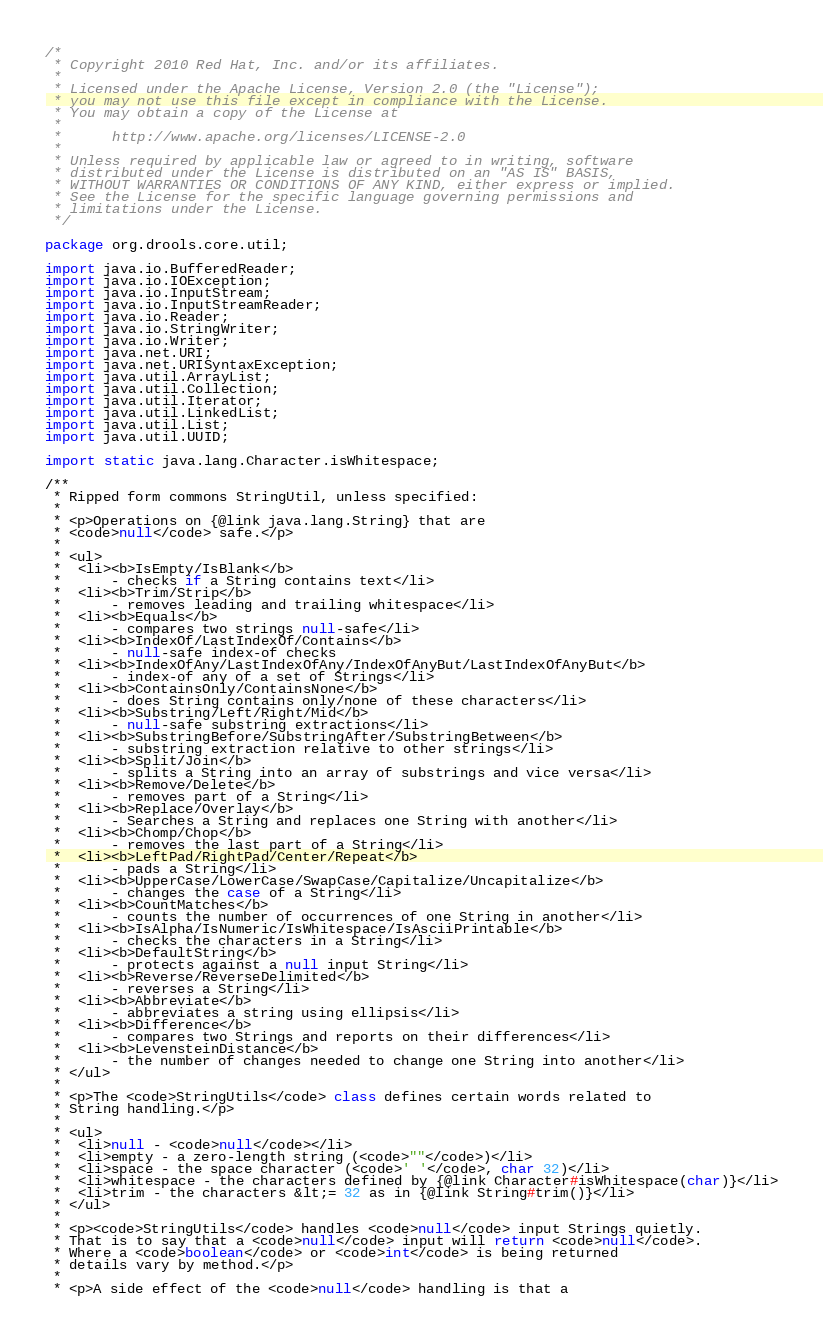Convert code to text. <code><loc_0><loc_0><loc_500><loc_500><_Java_>/*
 * Copyright 2010 Red Hat, Inc. and/or its affiliates.
 *
 * Licensed under the Apache License, Version 2.0 (the "License");
 * you may not use this file except in compliance with the License.
 * You may obtain a copy of the License at
 *
 *      http://www.apache.org/licenses/LICENSE-2.0
 *
 * Unless required by applicable law or agreed to in writing, software
 * distributed under the License is distributed on an "AS IS" BASIS,
 * WITHOUT WARRANTIES OR CONDITIONS OF ANY KIND, either express or implied.
 * See the License for the specific language governing permissions and
 * limitations under the License.
 */

package org.drools.core.util;

import java.io.BufferedReader;
import java.io.IOException;
import java.io.InputStream;
import java.io.InputStreamReader;
import java.io.Reader;
import java.io.StringWriter;
import java.io.Writer;
import java.net.URI;
import java.net.URISyntaxException;
import java.util.ArrayList;
import java.util.Collection;
import java.util.Iterator;
import java.util.LinkedList;
import java.util.List;
import java.util.UUID;

import static java.lang.Character.isWhitespace;

/**
 * Ripped form commons StringUtil, unless specified:
 * 
 * <p>Operations on {@link java.lang.String} that are
 * <code>null</code> safe.</p>
 *
 * <ul>
 *  <li><b>IsEmpty/IsBlank</b>
 *      - checks if a String contains text</li>
 *  <li><b>Trim/Strip</b>
 *      - removes leading and trailing whitespace</li>
 *  <li><b>Equals</b>
 *      - compares two strings null-safe</li>
 *  <li><b>IndexOf/LastIndexOf/Contains</b>
 *      - null-safe index-of checks
 *  <li><b>IndexOfAny/LastIndexOfAny/IndexOfAnyBut/LastIndexOfAnyBut</b>
 *      - index-of any of a set of Strings</li>
 *  <li><b>ContainsOnly/ContainsNone</b>
 *      - does String contains only/none of these characters</li>
 *  <li><b>Substring/Left/Right/Mid</b>
 *      - null-safe substring extractions</li>
 *  <li><b>SubstringBefore/SubstringAfter/SubstringBetween</b>
 *      - substring extraction relative to other strings</li>
 *  <li><b>Split/Join</b>
 *      - splits a String into an array of substrings and vice versa</li>
 *  <li><b>Remove/Delete</b>
 *      - removes part of a String</li>
 *  <li><b>Replace/Overlay</b>
 *      - Searches a String and replaces one String with another</li>
 *  <li><b>Chomp/Chop</b>
 *      - removes the last part of a String</li>
 *  <li><b>LeftPad/RightPad/Center/Repeat</b>
 *      - pads a String</li>
 *  <li><b>UpperCase/LowerCase/SwapCase/Capitalize/Uncapitalize</b>
 *      - changes the case of a String</li>
 *  <li><b>CountMatches</b>
 *      - counts the number of occurrences of one String in another</li>
 *  <li><b>IsAlpha/IsNumeric/IsWhitespace/IsAsciiPrintable</b>
 *      - checks the characters in a String</li>
 *  <li><b>DefaultString</b>
 *      - protects against a null input String</li>
 *  <li><b>Reverse/ReverseDelimited</b>
 *      - reverses a String</li>
 *  <li><b>Abbreviate</b>
 *      - abbreviates a string using ellipsis</li>
 *  <li><b>Difference</b>
 *      - compares two Strings and reports on their differences</li>
 *  <li><b>LevensteinDistance</b>
 *      - the number of changes needed to change one String into another</li>
 * </ul>
 *
 * <p>The <code>StringUtils</code> class defines certain words related to
 * String handling.</p>
 *
 * <ul>
 *  <li>null - <code>null</code></li>
 *  <li>empty - a zero-length string (<code>""</code>)</li>
 *  <li>space - the space character (<code>' '</code>, char 32)</li>
 *  <li>whitespace - the characters defined by {@link Character#isWhitespace(char)}</li>
 *  <li>trim - the characters &lt;= 32 as in {@link String#trim()}</li>
 * </ul>
 *
 * <p><code>StringUtils</code> handles <code>null</code> input Strings quietly.
 * That is to say that a <code>null</code> input will return <code>null</code>.
 * Where a <code>boolean</code> or <code>int</code> is being returned
 * details vary by method.</p>
 *
 * <p>A side effect of the <code>null</code> handling is that a</code> 